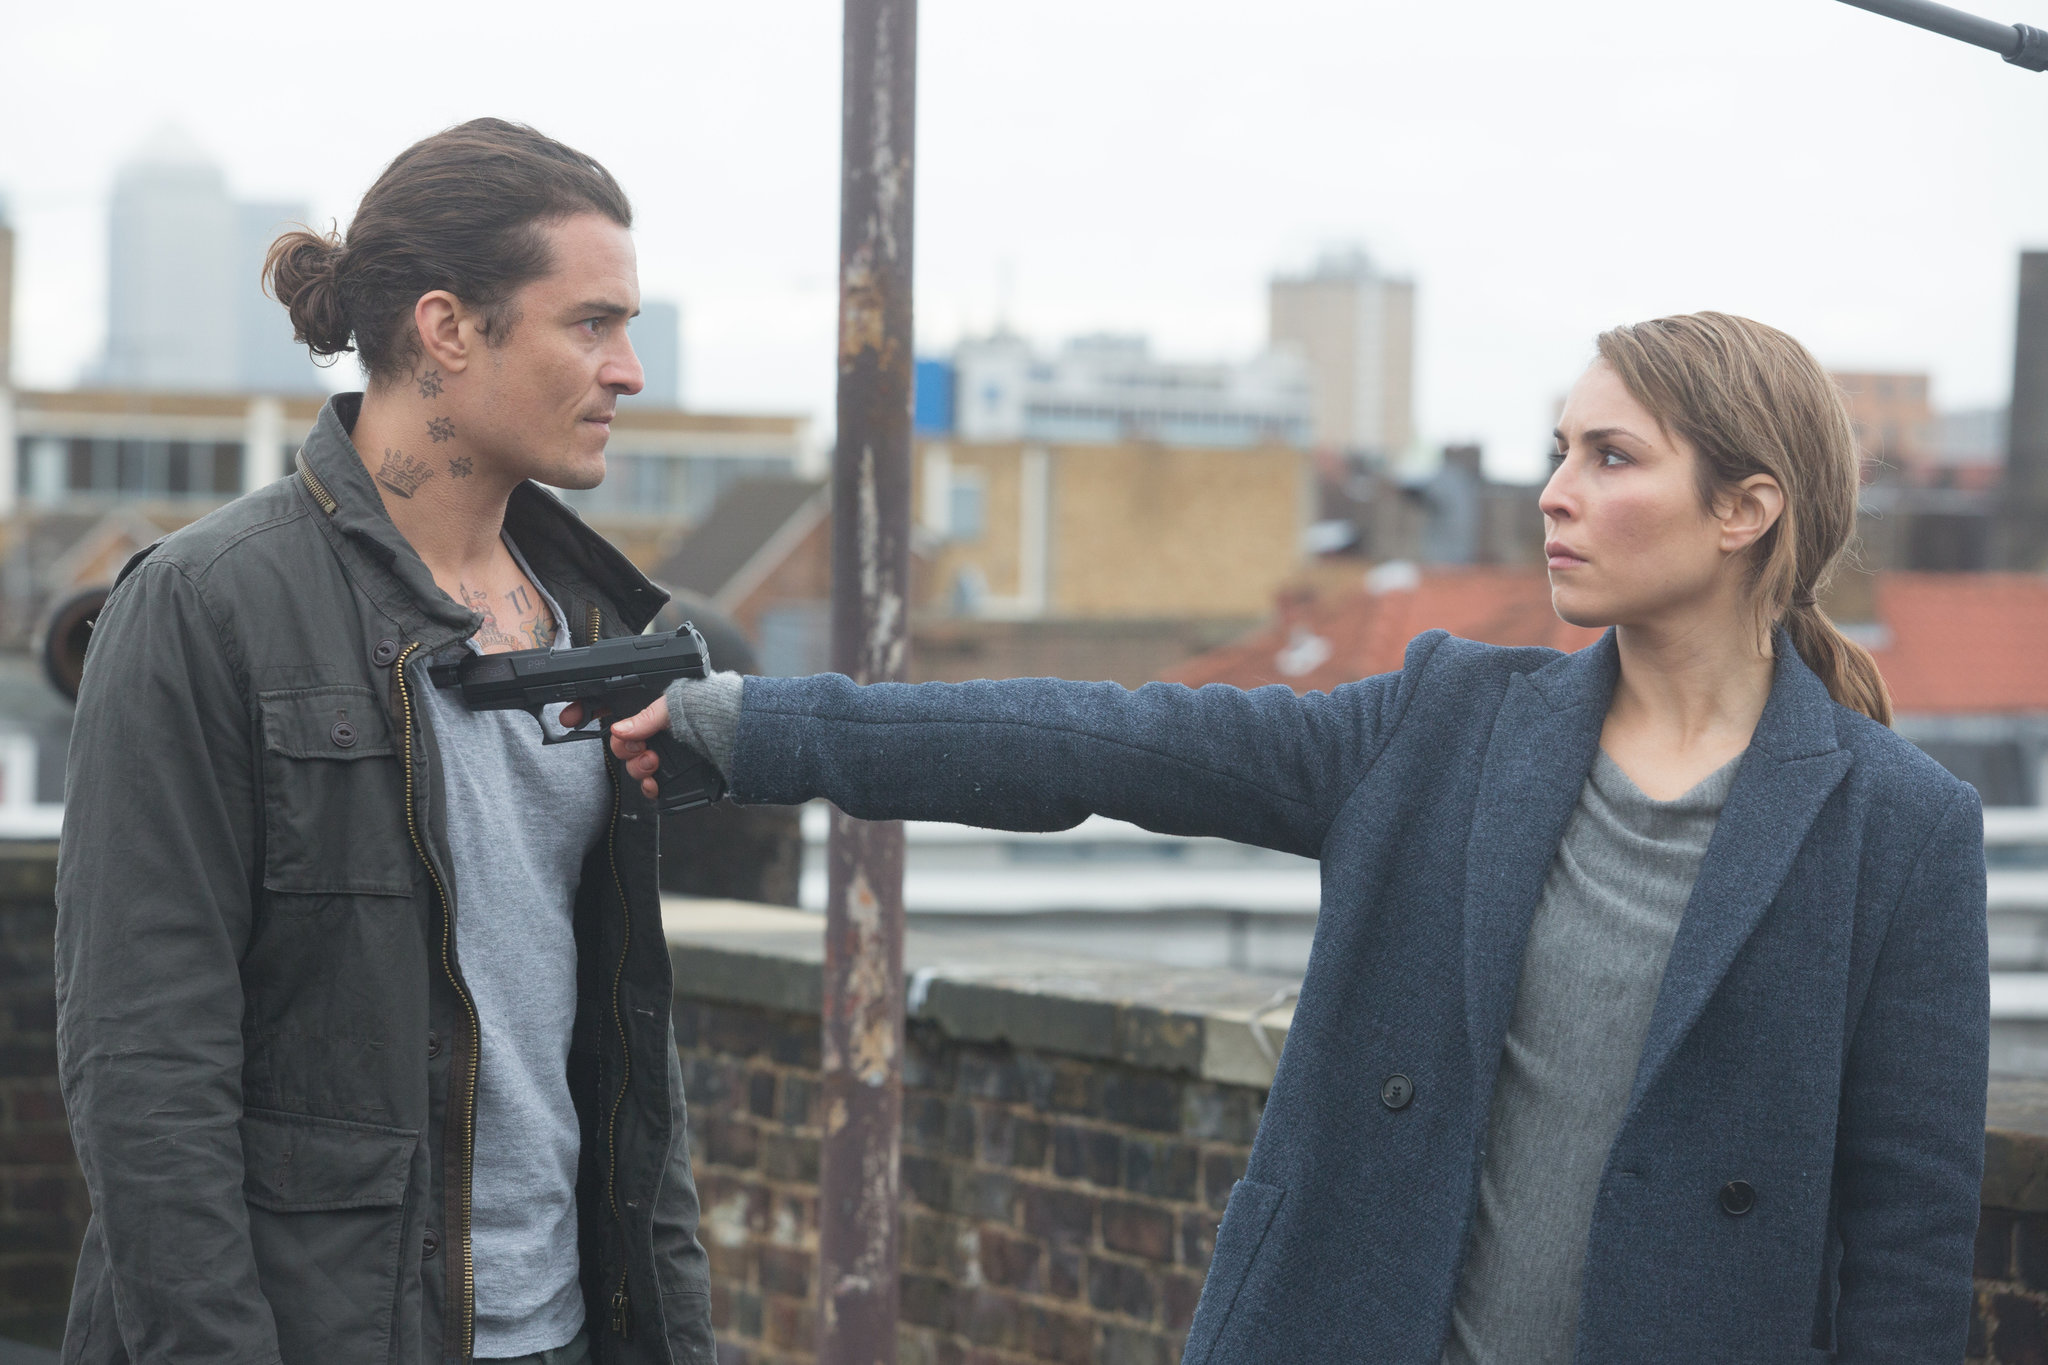What does this scene suggest about the characters' relationship? The scene suggests a complex and possibly antagonistic relationship between the two characters. The direct confrontation, combined with their intense expressions and the dramatic setting, implies a deep-seated conflict, hinting at themes of betrayal, rivalry, or a critical showdown in their respective narratives. 